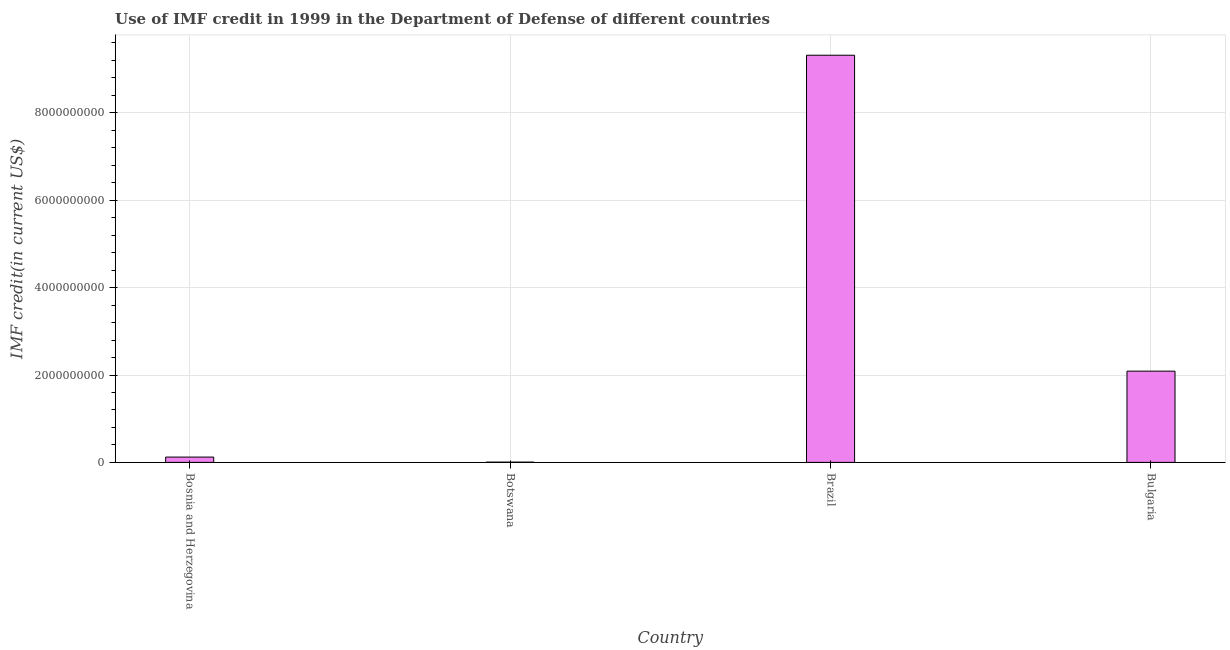Does the graph contain grids?
Your answer should be very brief. Yes. What is the title of the graph?
Offer a very short reply. Use of IMF credit in 1999 in the Department of Defense of different countries. What is the label or title of the Y-axis?
Offer a terse response. IMF credit(in current US$). What is the use of imf credit in dod in Bulgaria?
Ensure brevity in your answer.  2.09e+09. Across all countries, what is the maximum use of imf credit in dod?
Keep it short and to the point. 9.32e+09. Across all countries, what is the minimum use of imf credit in dod?
Make the answer very short. 5.98e+06. In which country was the use of imf credit in dod minimum?
Provide a succinct answer. Botswana. What is the sum of the use of imf credit in dod?
Your answer should be very brief. 1.15e+1. What is the difference between the use of imf credit in dod in Bosnia and Herzegovina and Bulgaria?
Your answer should be compact. -1.97e+09. What is the average use of imf credit in dod per country?
Keep it short and to the point. 2.88e+09. What is the median use of imf credit in dod?
Give a very brief answer. 1.11e+09. In how many countries, is the use of imf credit in dod greater than 6800000000 US$?
Offer a very short reply. 1. What is the ratio of the use of imf credit in dod in Bosnia and Herzegovina to that in Botswana?
Offer a very short reply. 20.39. Is the use of imf credit in dod in Bosnia and Herzegovina less than that in Botswana?
Provide a succinct answer. No. What is the difference between the highest and the second highest use of imf credit in dod?
Your answer should be very brief. 7.23e+09. What is the difference between the highest and the lowest use of imf credit in dod?
Make the answer very short. 9.31e+09. Are all the bars in the graph horizontal?
Offer a very short reply. No. Are the values on the major ticks of Y-axis written in scientific E-notation?
Offer a very short reply. No. What is the IMF credit(in current US$) in Bosnia and Herzegovina?
Give a very brief answer. 1.22e+08. What is the IMF credit(in current US$) of Botswana?
Your response must be concise. 5.98e+06. What is the IMF credit(in current US$) in Brazil?
Provide a succinct answer. 9.32e+09. What is the IMF credit(in current US$) of Bulgaria?
Ensure brevity in your answer.  2.09e+09. What is the difference between the IMF credit(in current US$) in Bosnia and Herzegovina and Botswana?
Give a very brief answer. 1.16e+08. What is the difference between the IMF credit(in current US$) in Bosnia and Herzegovina and Brazil?
Your answer should be compact. -9.20e+09. What is the difference between the IMF credit(in current US$) in Bosnia and Herzegovina and Bulgaria?
Provide a succinct answer. -1.97e+09. What is the difference between the IMF credit(in current US$) in Botswana and Brazil?
Your answer should be very brief. -9.31e+09. What is the difference between the IMF credit(in current US$) in Botswana and Bulgaria?
Keep it short and to the point. -2.08e+09. What is the difference between the IMF credit(in current US$) in Brazil and Bulgaria?
Ensure brevity in your answer.  7.23e+09. What is the ratio of the IMF credit(in current US$) in Bosnia and Herzegovina to that in Botswana?
Give a very brief answer. 20.39. What is the ratio of the IMF credit(in current US$) in Bosnia and Herzegovina to that in Brazil?
Your response must be concise. 0.01. What is the ratio of the IMF credit(in current US$) in Bosnia and Herzegovina to that in Bulgaria?
Make the answer very short. 0.06. What is the ratio of the IMF credit(in current US$) in Botswana to that in Bulgaria?
Give a very brief answer. 0. What is the ratio of the IMF credit(in current US$) in Brazil to that in Bulgaria?
Provide a short and direct response. 4.46. 